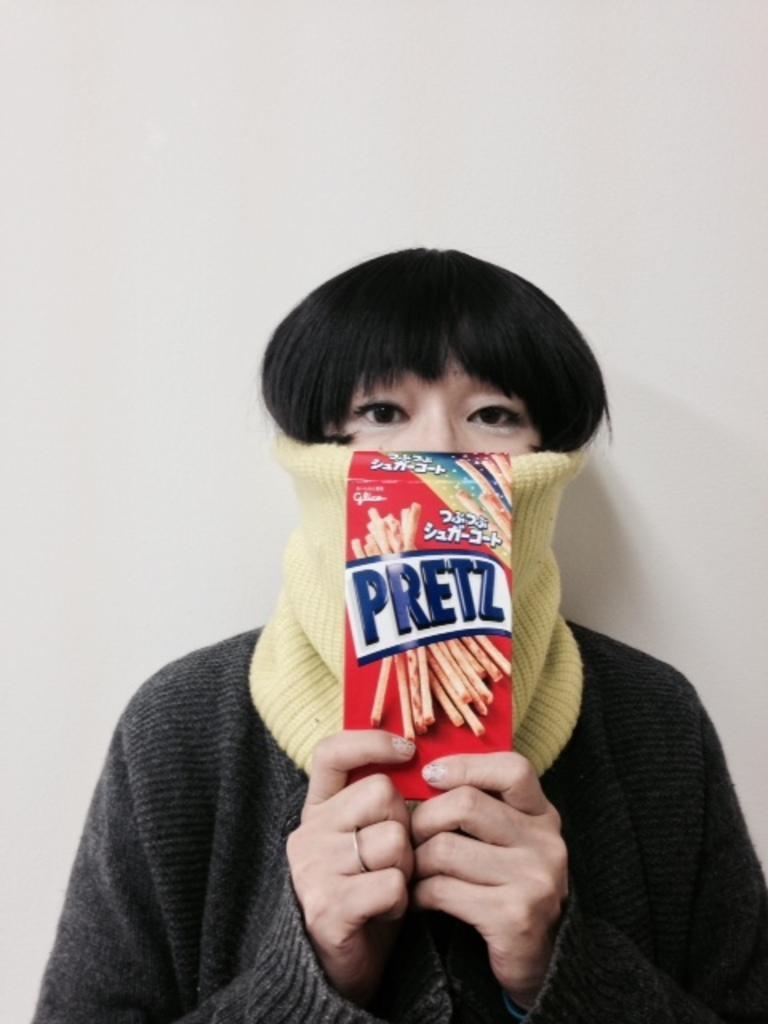Please provide a concise description of this image. In this image the background is gray in color. In the middle of the image there is a person wearing a face mask and there is a paper with a text on it. 